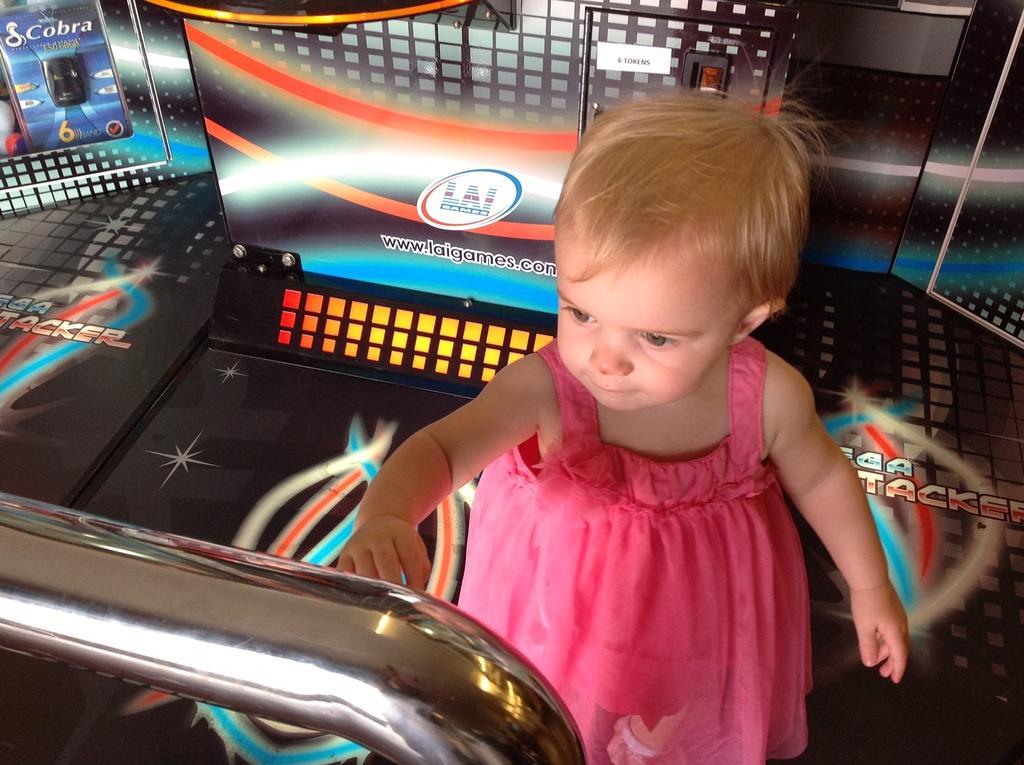Describe this image in one or two sentences. In this image there is a girl towards the bottom of the image, there is a floor towards the right of the image, there is text on the floor, there is a metal towards the bottom of the image, there is a wall towards the top of the image, there is text on the wall. 